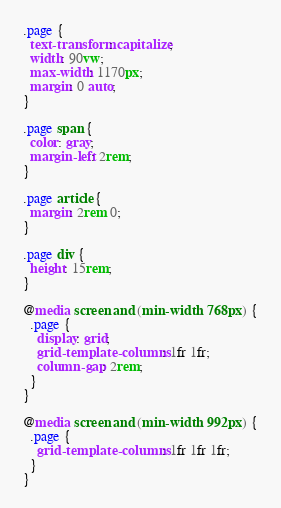Convert code to text. <code><loc_0><loc_0><loc_500><loc_500><_CSS_>.page {
  text-transform: capitalize;
  width: 90vw;
  max-width: 1170px;
  margin: 0 auto;
}

.page span {
  color: gray;
  margin-left: 2rem;
}

.page article {
  margin: 2rem 0;
}

.page div {
  height: 15rem;
}

@media screen and (min-width: 768px) {
  .page {
    display: grid;
    grid-template-columns: 1fr 1fr;
    column-gap: 2rem;
  }
}

@media screen and (min-width: 992px) {
  .page {
    grid-template-columns: 1fr 1fr 1fr;
  }
}
</code> 